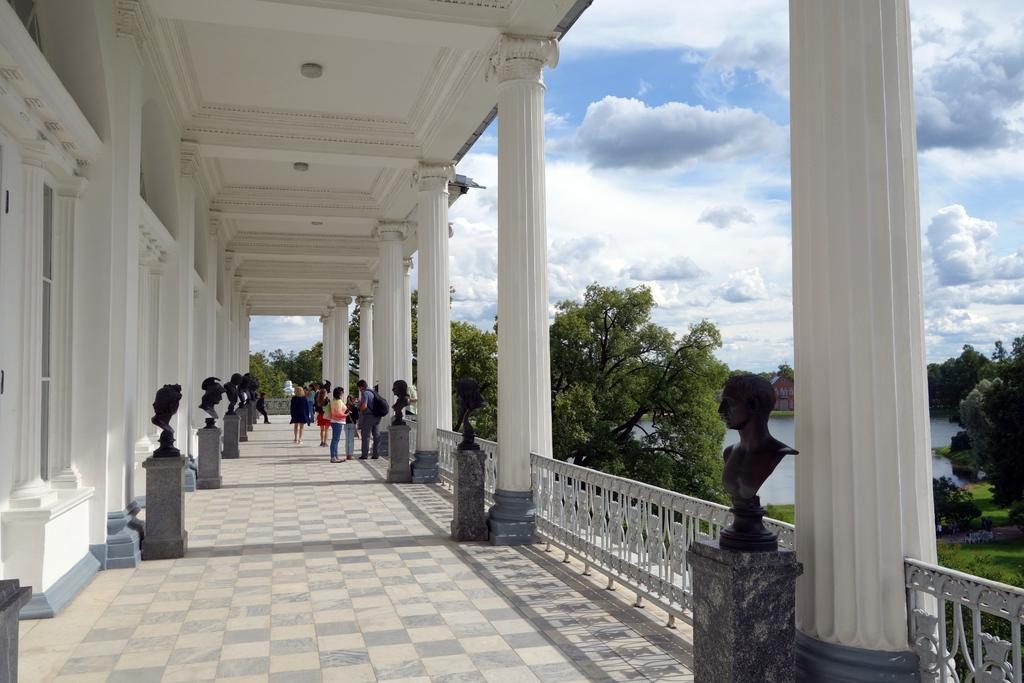Could you give a brief overview of what you see in this image? In the image on the floor there are pedestals with statues. And also there are few people standing on the floor. On the left side of the image there is a wall. And also there are pillars. Behind the building there are trees. And also there is water and sky with clouds. 